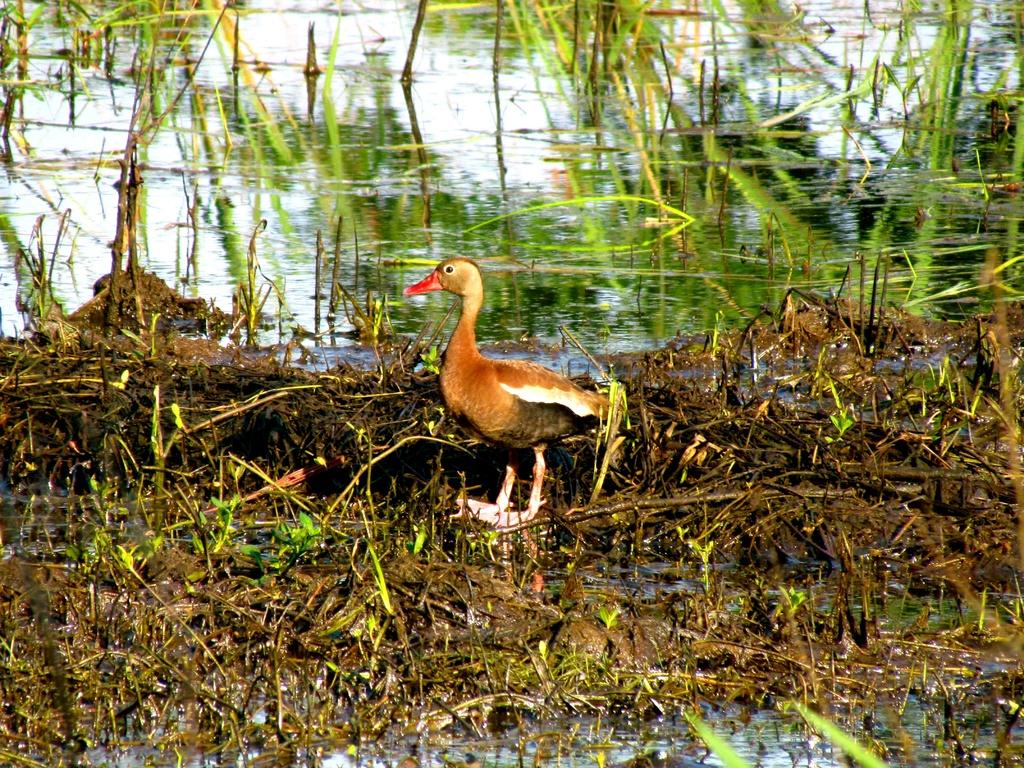What type of animal can be seen in the image? There is a bird in the image. Where is the bird located in the image? The bird is standing on the ground. What can be seen in the water in the image? There are plants in the water in the image. What type of humor can be seen in the bird's expression in the image? There is no indication of the bird's expression in the image, and therefore no humor can be observed. 